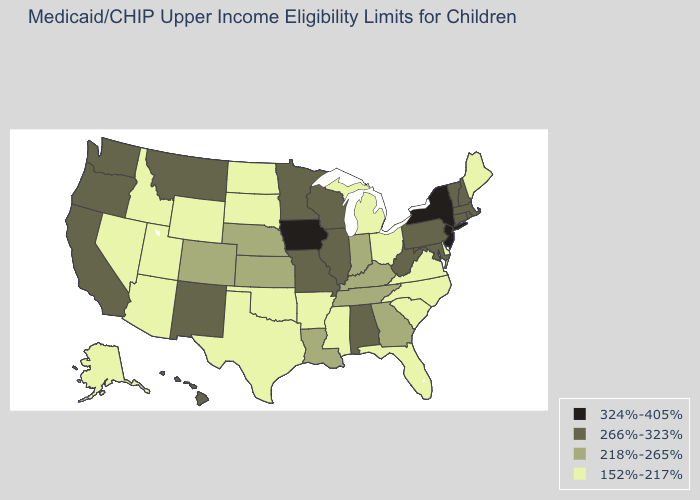Among the states that border Arizona , which have the highest value?
Write a very short answer. California, New Mexico. What is the lowest value in states that border Massachusetts?
Short answer required. 266%-323%. What is the lowest value in the USA?
Short answer required. 152%-217%. Does Missouri have a higher value than South Dakota?
Write a very short answer. Yes. What is the value of Arkansas?
Answer briefly. 152%-217%. What is the value of Maryland?
Give a very brief answer. 266%-323%. What is the lowest value in the USA?
Quick response, please. 152%-217%. What is the highest value in the MidWest ?
Quick response, please. 324%-405%. Name the states that have a value in the range 324%-405%?
Give a very brief answer. Iowa, New Jersey, New York. What is the highest value in the USA?
Short answer required. 324%-405%. What is the value of Nevada?
Write a very short answer. 152%-217%. Among the states that border West Virginia , does Kentucky have the highest value?
Give a very brief answer. No. What is the lowest value in the West?
Quick response, please. 152%-217%. What is the highest value in states that border Nebraska?
Give a very brief answer. 324%-405%. Does Maine have the lowest value in the Northeast?
Answer briefly. Yes. 